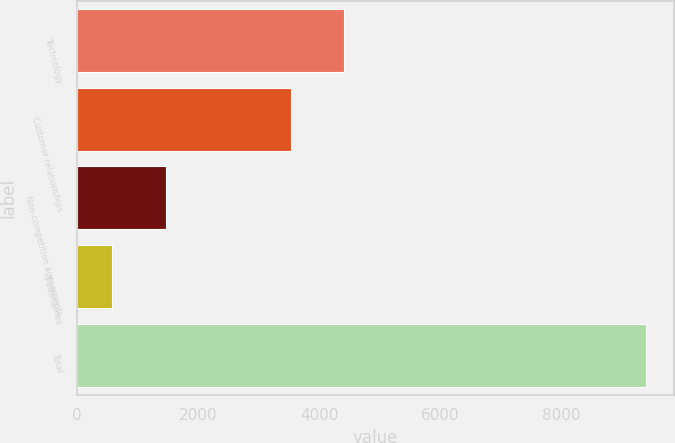Convert chart. <chart><loc_0><loc_0><loc_500><loc_500><bar_chart><fcel>Technology<fcel>Customer relationships<fcel>Non-competition agreements<fcel>Tradenames<fcel>Total<nl><fcel>4410<fcel>3530<fcel>1470<fcel>590<fcel>9390<nl></chart> 